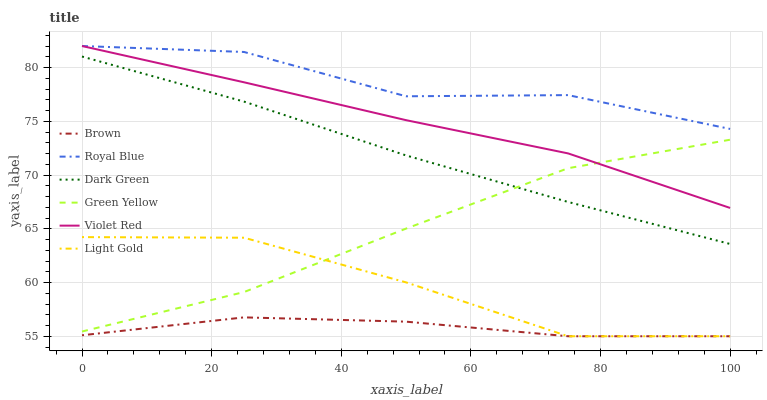Does Brown have the minimum area under the curve?
Answer yes or no. Yes. Does Royal Blue have the maximum area under the curve?
Answer yes or no. Yes. Does Violet Red have the minimum area under the curve?
Answer yes or no. No. Does Violet Red have the maximum area under the curve?
Answer yes or no. No. Is Dark Green the smoothest?
Answer yes or no. Yes. Is Royal Blue the roughest?
Answer yes or no. Yes. Is Violet Red the smoothest?
Answer yes or no. No. Is Violet Red the roughest?
Answer yes or no. No. Does Brown have the lowest value?
Answer yes or no. Yes. Does Violet Red have the lowest value?
Answer yes or no. No. Does Royal Blue have the highest value?
Answer yes or no. Yes. Does Green Yellow have the highest value?
Answer yes or no. No. Is Brown less than Royal Blue?
Answer yes or no. Yes. Is Royal Blue greater than Dark Green?
Answer yes or no. Yes. Does Light Gold intersect Green Yellow?
Answer yes or no. Yes. Is Light Gold less than Green Yellow?
Answer yes or no. No. Is Light Gold greater than Green Yellow?
Answer yes or no. No. Does Brown intersect Royal Blue?
Answer yes or no. No. 